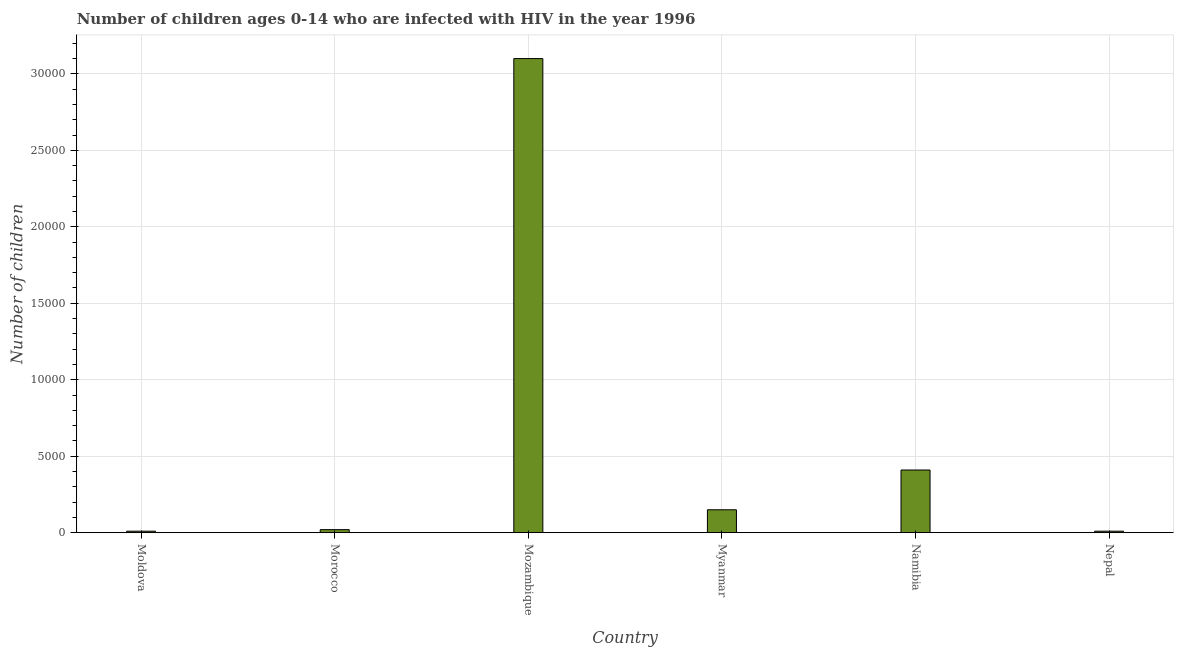Does the graph contain grids?
Ensure brevity in your answer.  Yes. What is the title of the graph?
Make the answer very short. Number of children ages 0-14 who are infected with HIV in the year 1996. What is the label or title of the Y-axis?
Your answer should be very brief. Number of children. What is the number of children living with hiv in Namibia?
Provide a short and direct response. 4100. Across all countries, what is the maximum number of children living with hiv?
Offer a terse response. 3.10e+04. In which country was the number of children living with hiv maximum?
Ensure brevity in your answer.  Mozambique. In which country was the number of children living with hiv minimum?
Keep it short and to the point. Moldova. What is the sum of the number of children living with hiv?
Make the answer very short. 3.70e+04. What is the difference between the number of children living with hiv in Moldova and Mozambique?
Ensure brevity in your answer.  -3.09e+04. What is the average number of children living with hiv per country?
Offer a very short reply. 6166. What is the median number of children living with hiv?
Make the answer very short. 850. What is the ratio of the number of children living with hiv in Morocco to that in Mozambique?
Provide a succinct answer. 0.01. What is the difference between the highest and the second highest number of children living with hiv?
Provide a short and direct response. 2.69e+04. What is the difference between the highest and the lowest number of children living with hiv?
Offer a very short reply. 3.09e+04. How many bars are there?
Your response must be concise. 6. Are all the bars in the graph horizontal?
Your answer should be very brief. No. How many countries are there in the graph?
Ensure brevity in your answer.  6. What is the difference between two consecutive major ticks on the Y-axis?
Your response must be concise. 5000. Are the values on the major ticks of Y-axis written in scientific E-notation?
Your response must be concise. No. What is the Number of children in Morocco?
Provide a short and direct response. 200. What is the Number of children of Mozambique?
Your response must be concise. 3.10e+04. What is the Number of children of Myanmar?
Your answer should be very brief. 1500. What is the Number of children of Namibia?
Make the answer very short. 4100. What is the Number of children in Nepal?
Keep it short and to the point. 100. What is the difference between the Number of children in Moldova and Morocco?
Your response must be concise. -100. What is the difference between the Number of children in Moldova and Mozambique?
Make the answer very short. -3.09e+04. What is the difference between the Number of children in Moldova and Myanmar?
Make the answer very short. -1400. What is the difference between the Number of children in Moldova and Namibia?
Keep it short and to the point. -4000. What is the difference between the Number of children in Morocco and Mozambique?
Your answer should be compact. -3.08e+04. What is the difference between the Number of children in Morocco and Myanmar?
Offer a very short reply. -1300. What is the difference between the Number of children in Morocco and Namibia?
Offer a very short reply. -3900. What is the difference between the Number of children in Mozambique and Myanmar?
Provide a succinct answer. 2.95e+04. What is the difference between the Number of children in Mozambique and Namibia?
Your answer should be very brief. 2.69e+04. What is the difference between the Number of children in Mozambique and Nepal?
Provide a succinct answer. 3.09e+04. What is the difference between the Number of children in Myanmar and Namibia?
Keep it short and to the point. -2600. What is the difference between the Number of children in Myanmar and Nepal?
Give a very brief answer. 1400. What is the difference between the Number of children in Namibia and Nepal?
Offer a terse response. 4000. What is the ratio of the Number of children in Moldova to that in Mozambique?
Provide a short and direct response. 0. What is the ratio of the Number of children in Moldova to that in Myanmar?
Give a very brief answer. 0.07. What is the ratio of the Number of children in Moldova to that in Namibia?
Provide a short and direct response. 0.02. What is the ratio of the Number of children in Moldova to that in Nepal?
Your response must be concise. 1. What is the ratio of the Number of children in Morocco to that in Mozambique?
Your response must be concise. 0.01. What is the ratio of the Number of children in Morocco to that in Myanmar?
Offer a very short reply. 0.13. What is the ratio of the Number of children in Morocco to that in Namibia?
Offer a terse response. 0.05. What is the ratio of the Number of children in Morocco to that in Nepal?
Give a very brief answer. 2. What is the ratio of the Number of children in Mozambique to that in Myanmar?
Make the answer very short. 20.67. What is the ratio of the Number of children in Mozambique to that in Namibia?
Provide a succinct answer. 7.56. What is the ratio of the Number of children in Mozambique to that in Nepal?
Give a very brief answer. 310. What is the ratio of the Number of children in Myanmar to that in Namibia?
Offer a terse response. 0.37. 